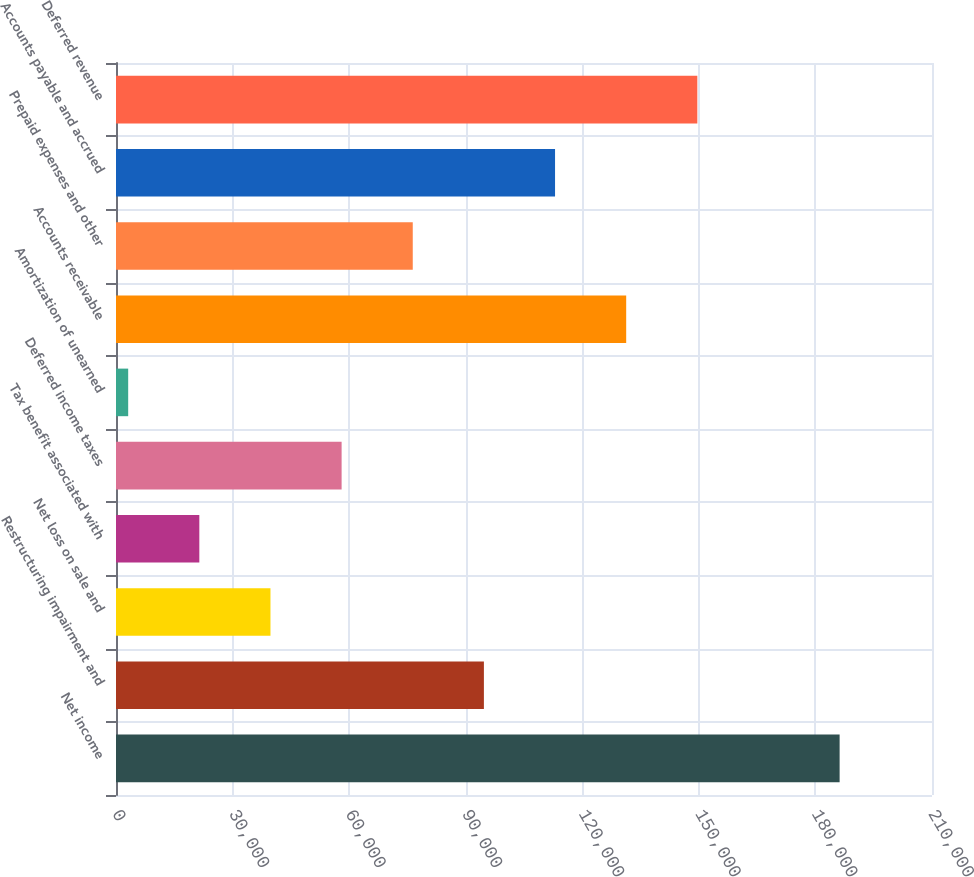Convert chart to OTSL. <chart><loc_0><loc_0><loc_500><loc_500><bar_chart><fcel>Net income<fcel>Restructuring impairment and<fcel>Net loss on sale and<fcel>Tax benefit associated with<fcel>Deferred income taxes<fcel>Amortization of unearned<fcel>Accounts receivable<fcel>Prepaid expenses and other<fcel>Accounts payable and accrued<fcel>Deferred revenue<nl><fcel>186225<fcel>94680.5<fcel>39753.8<fcel>21444.9<fcel>58062.7<fcel>3136<fcel>131298<fcel>76371.6<fcel>112989<fcel>149607<nl></chart> 